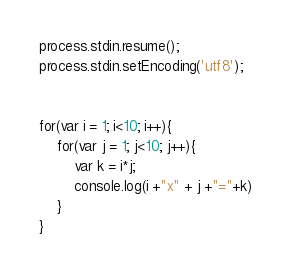Convert code to text. <code><loc_0><loc_0><loc_500><loc_500><_JavaScript_>process.stdin.resume();
process.stdin.setEncoding('utf8');


for(var i = 1; i<10; i++){
    for(var j = 1; j<10; j++){
        var k = i*j;
        console.log(i +"x" + j +"="+k)
    }   
}</code> 